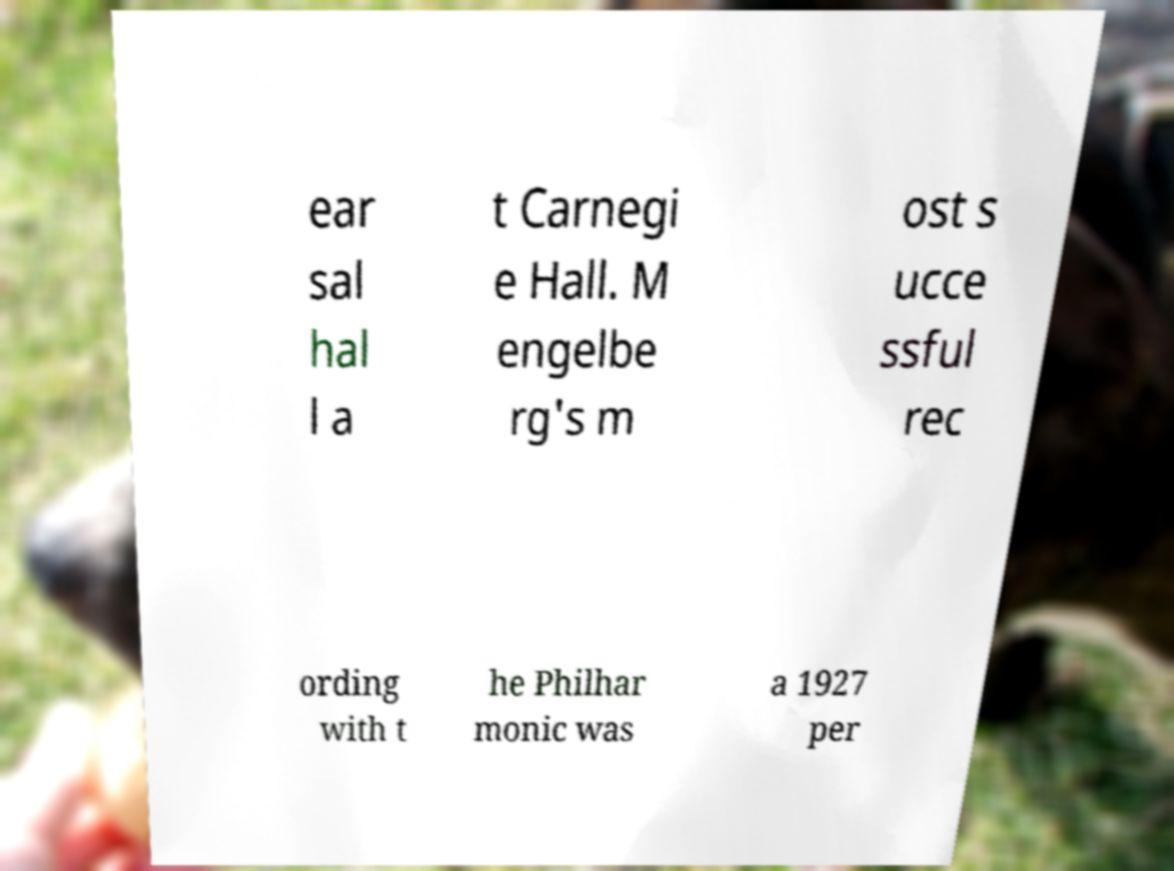Could you extract and type out the text from this image? ear sal hal l a t Carnegi e Hall. M engelbe rg's m ost s ucce ssful rec ording with t he Philhar monic was a 1927 per 